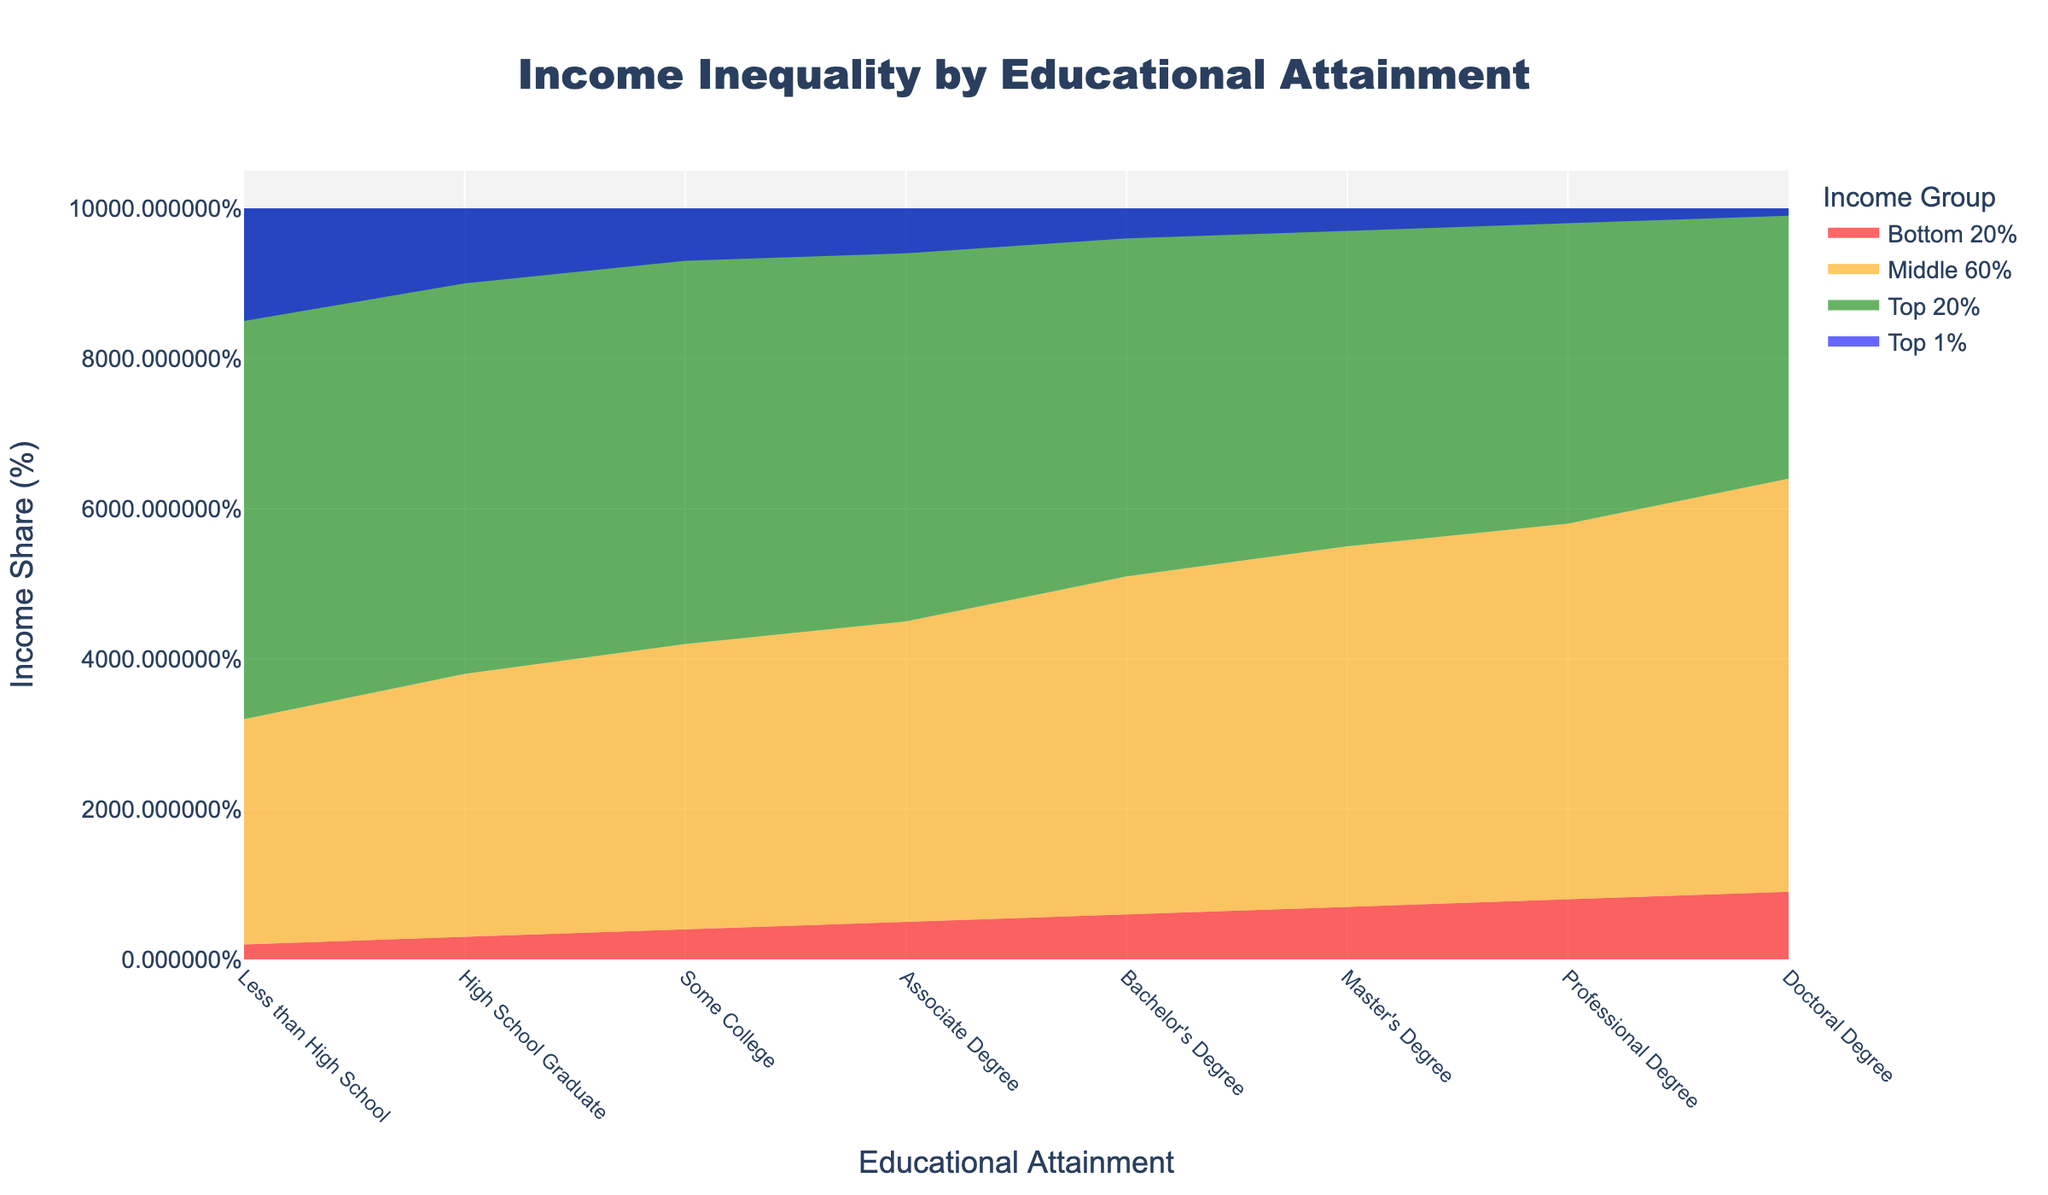What is the title of the figure? The figure's title is typically found at the top of the chart and is labeled in a larger font compared to other text elements.
Answer: Income Inequality by Educational Attainment What does the red section in the Stream graph represent? The red section at the bottom of the graph indicates the income share of the Bottom 20% across educational attainment levels. This can be determined from the legend.
Answer: Bottom 20% Which educational attainment level has the highest income share for the Bottom 20%? By examining the height of the red section along the educational attainment axis, the highest point indicates the highest income share for the Bottom 20%.
Answer: Doctoral Degree Compare the income share of the Top 1% for High School Graduates and Master's Degree holders. Which is larger? First, locate the blue sections representing the Top 1% for High School Graduates and Master's Degree holders in the graph. Then compare their sizes. The blue section for High School Graduates is larger.
Answer: High School Graduates What is the income share of the Middle 60% for those with a Bachelor's Degree? Find the orange section representing the Middle 60% for those with a Bachelor's Degree in the graph and refer to its height.
Answer: 45% How does the income share of the Top 1% change as educational attainment increases? Follow the blue section across levels of educational attainment and observe its height reduction as educational attainment increases, ranging from 15% to 1%.
Answer: It decreases What is the combined income share of the Bottom 20% and Middle 60% for those with a Doctoral Degree? The Bottom 20% is 9%, and the Middle 60% is 55%. Adding these two values gives: 9% + 55% = 64%.
Answer: 64% Which educational attainment level has the most balanced income distribution between the Bottom 20% and the Top 1%? A balanced income distribution can be identified where the gap between the income shares of the Bottom 20% and the Top 1% is the smallest. Look at the narrowest difference between the top of the red section and the bottom of the blue section.
Answer: Doctoral Degree What is the visual pattern of the Middle 60%'s income share as educational attainment increases? Observing the orange section across increasing educational attainment levels, the Middle 60%'s income share shows a consistent increase in height indicating an increase in income share.
Answer: It increases Does the income share of the Top 20% and Top 1% combined ever exceed 70%? Combine the heights of the green (Top 20%) and blue (Top 1%) sections at their highest combined point, but note that the highest combined value does not exceed 70%.
Answer: No 